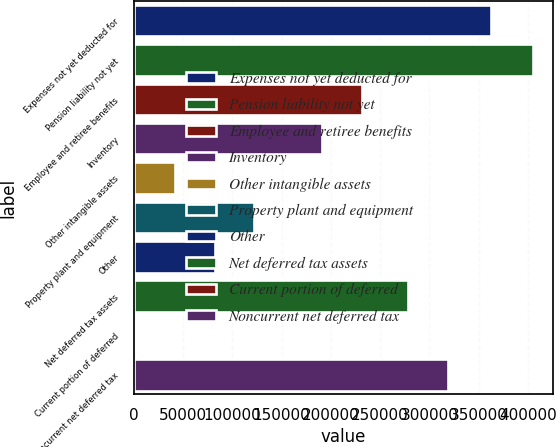Convert chart to OTSL. <chart><loc_0><loc_0><loc_500><loc_500><bar_chart><fcel>Expenses not yet deducted for<fcel>Pension liability not yet<fcel>Employee and retiree benefits<fcel>Inventory<fcel>Other intangible assets<fcel>Property plant and equipment<fcel>Other<fcel>Net deferred tax assets<fcel>Current portion of deferred<fcel>Noncurrent net deferred tax<nl><fcel>362265<fcel>405048<fcel>231431<fcel>191047<fcel>41594.7<fcel>122362<fcel>81978.4<fcel>278252<fcel>1211<fcel>318636<nl></chart> 